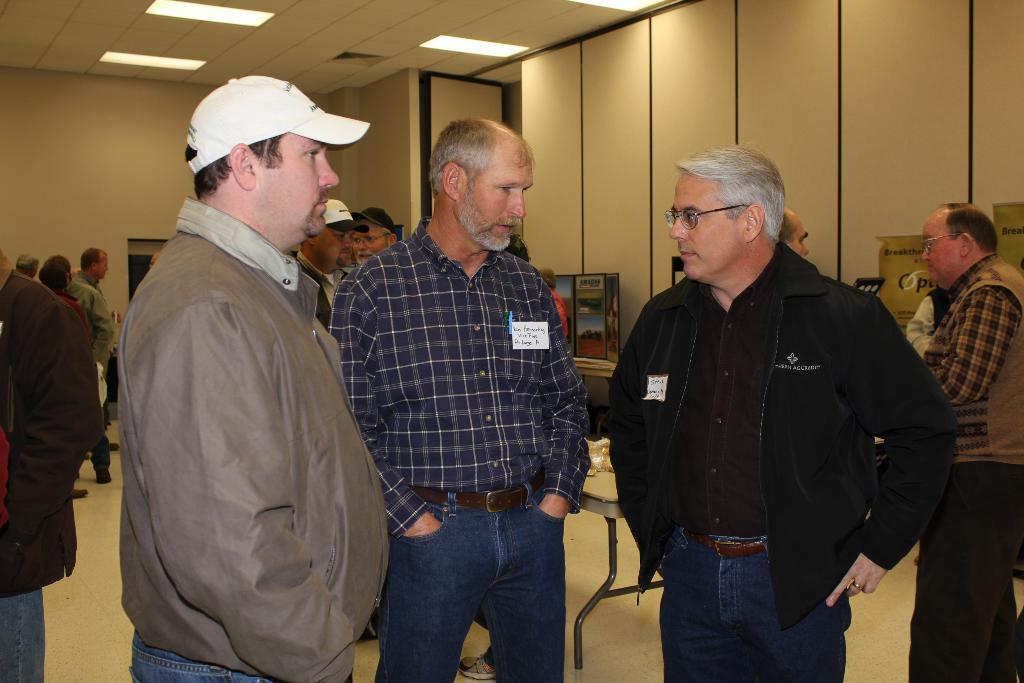How many men are in the foreground of the image? There are three men standing in the foreground of the image. What can be seen in the background of the image? There are people, a table, objects, a wall, and lights on the ceiling in the background of the image. Can you describe the table in the background of the image? Unfortunately, the facts provided do not give any details about the table in the background. What type of objects are present in the background of the image? The facts provided do not specify the type of objects in the background. What color is the pie that the man is holding in the image? There is no pie present in the image. How many eyes can be seen on the man in the image? The facts provided do not mention any specific details about the men's eyes. 